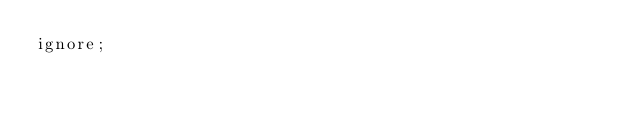<code> <loc_0><loc_0><loc_500><loc_500><_SQL_>ignore;</code> 